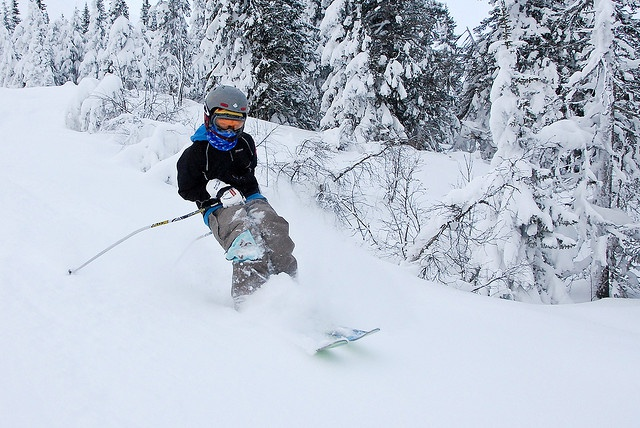Describe the objects in this image and their specific colors. I can see people in lightgray, black, gray, and darkgray tones, skis in lightgray, lightblue, and darkgray tones, and snowboard in lightgray, lavender, darkgray, and lightblue tones in this image. 